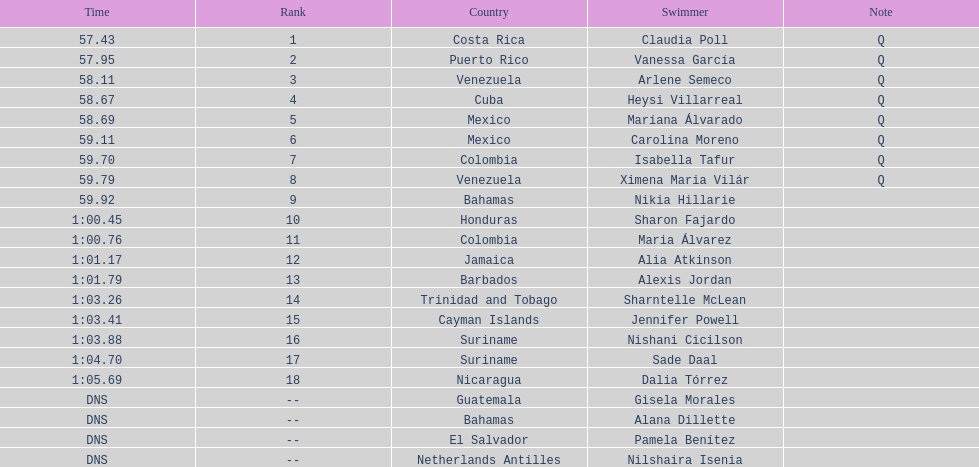What was claudia roll's time? 57.43. 